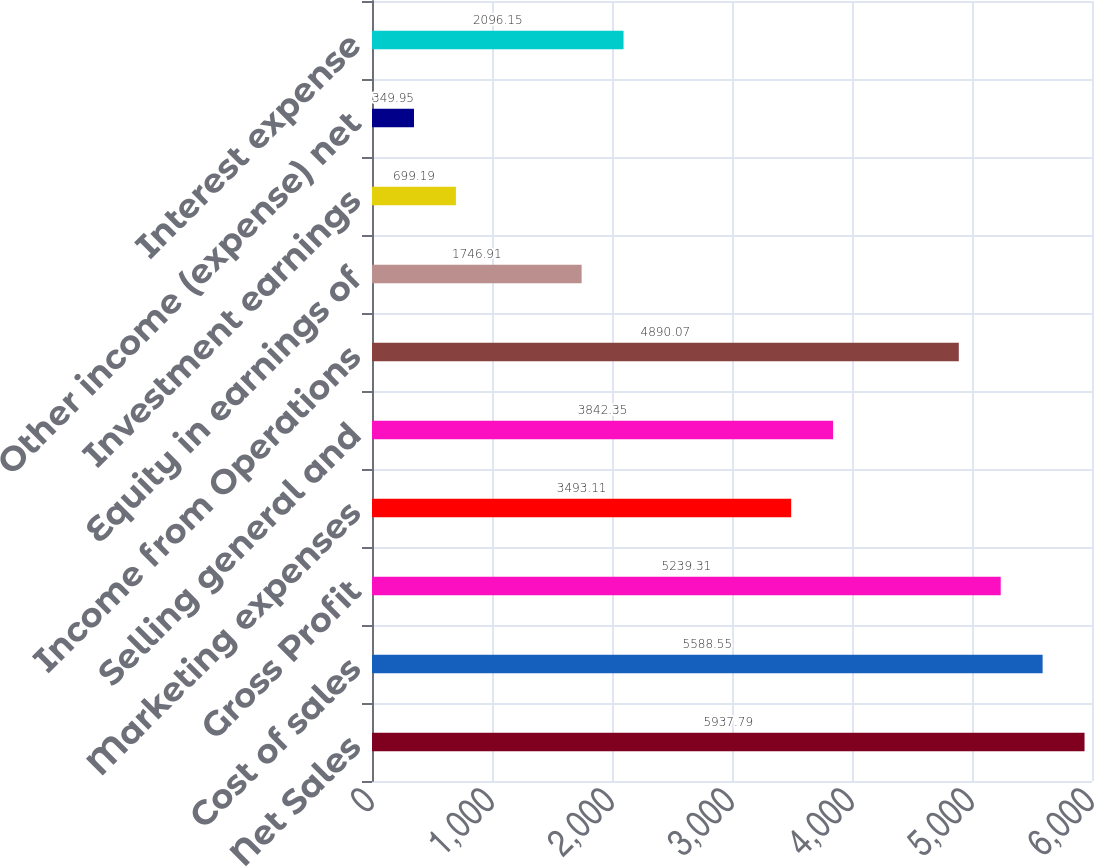Convert chart. <chart><loc_0><loc_0><loc_500><loc_500><bar_chart><fcel>Net Sales<fcel>Cost of sales<fcel>Gross Profit<fcel>Marketing expenses<fcel>Selling general and<fcel>Income from Operations<fcel>Equity in earnings of<fcel>Investment earnings<fcel>Other income (expense) net<fcel>Interest expense<nl><fcel>5937.79<fcel>5588.55<fcel>5239.31<fcel>3493.11<fcel>3842.35<fcel>4890.07<fcel>1746.91<fcel>699.19<fcel>349.95<fcel>2096.15<nl></chart> 